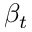<formula> <loc_0><loc_0><loc_500><loc_500>\beta _ { t }</formula> 